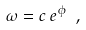<formula> <loc_0><loc_0><loc_500><loc_500>\omega = c \, e ^ { \phi } \ ,</formula> 